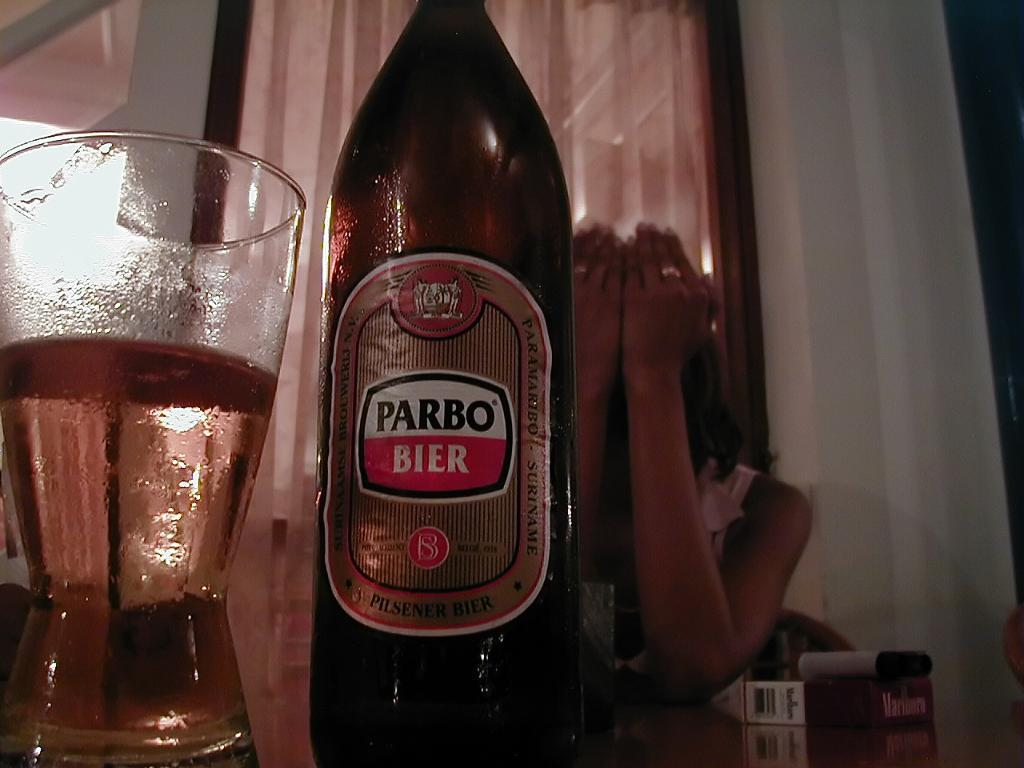<image>
Summarize the visual content of the image. bottle of Parbo Bier next to a half full glass 